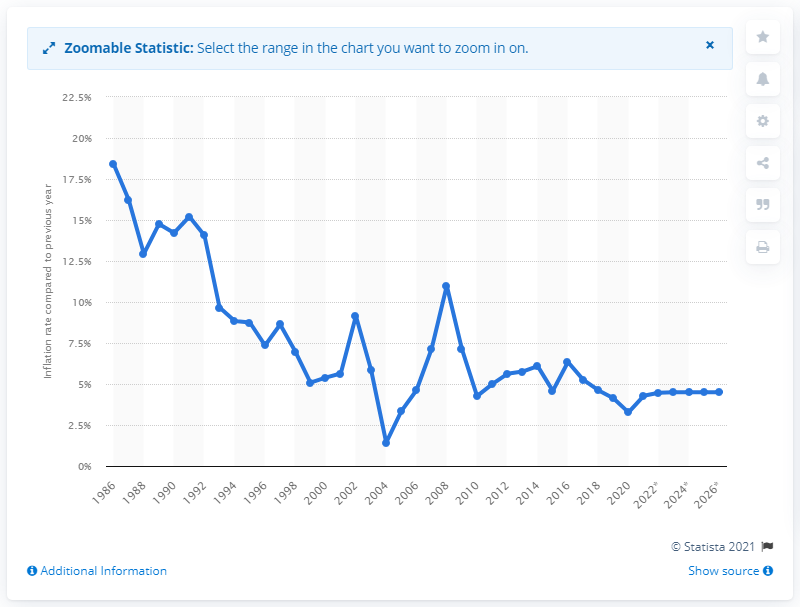Highlight a few significant elements in this photo. South Africa's inflation rate is expected to stabilize at 4.5% in the future," according to forecasts. The inflation rate in South Africa is 4.5%. 